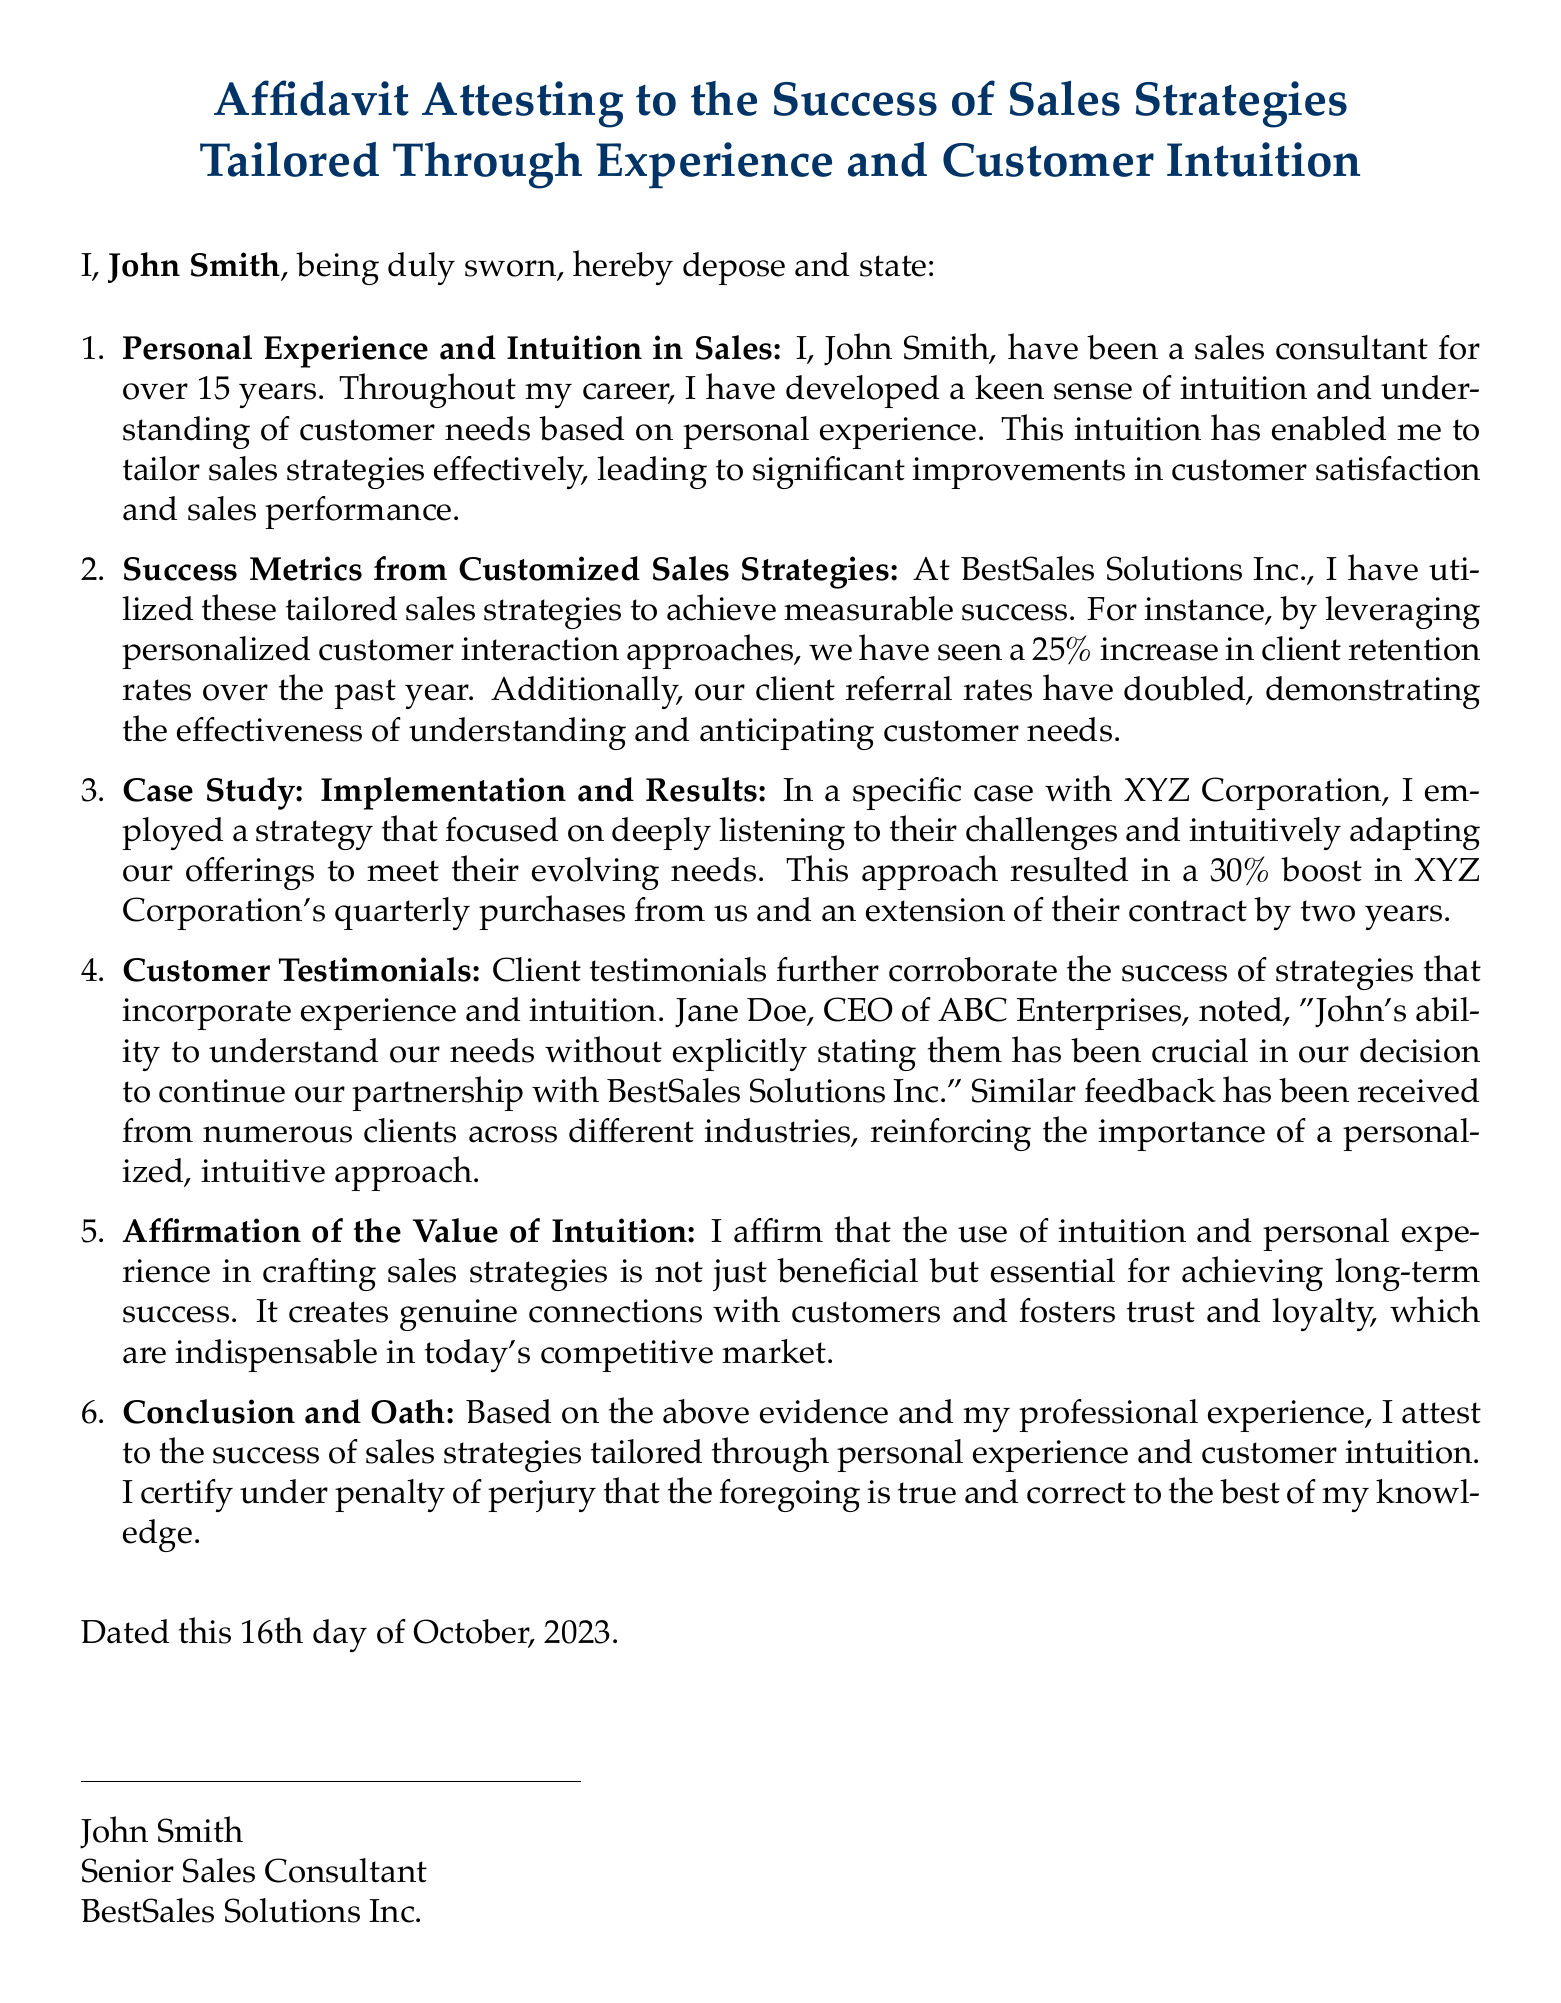what is the name of the affiant? The name of the affiant is stated at the beginning of the document as John Smith.
Answer: John Smith how many years of experience does John Smith have in sales? The document specifies that John Smith has been a sales consultant for over 15 years.
Answer: 15 years what percentage increase in client retention rates was achieved? The affidavit mentions a 25% increase in client retention rates over the past year.
Answer: 25% what was the specific case highlighted in the affidavit? The case highlighted in the affidavit is with XYZ Corporation.
Answer: XYZ Corporation who is the CEO of ABC Enterprises mentioned in the testimonials? The CEO of ABC Enterprises mentioned is Jane Doe.
Answer: Jane Doe what type of approach led to a boost in quarterly purchases at XYZ Corporation? The affidavit states that a strategy focusing on deeply listening to their challenges helped achieve this.
Answer: Listening to challenges what is John Smith's role at BestSales Solutions Inc.? His role is specified as Senior Sales Consultant in the document.
Answer: Senior Sales Consultant what is the date on which the affidavit was executed? The executed date of the affidavit is the 16th day of October, 2023.
Answer: October 16, 2023 what did John Smith affirm regarding the use of intuition in sales strategies? John Smith affirmed that using intuition is essential for achieving long-term success.
Answer: Essential for success what was the result of the personalized customer interaction approaches? The document states that these approaches resulted in a doubled client referral rate.
Answer: Doubled referral rates 